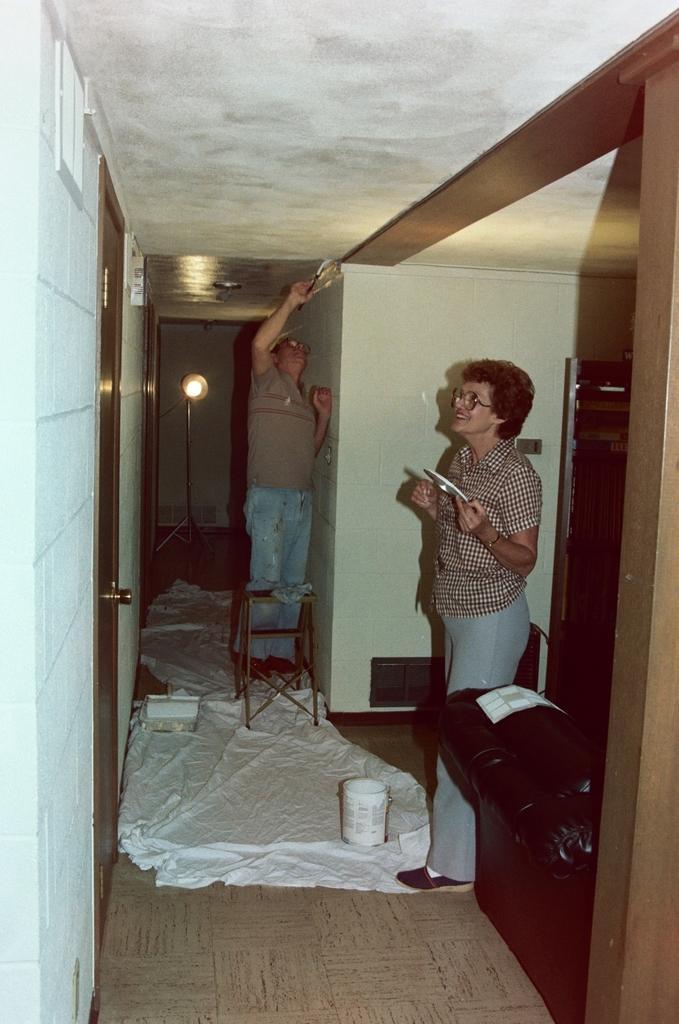How would you summarize this image in a sentence or two? In this image I can see two persons on the floor, cover and some objects. In the background I can see a wall, light, door and a chair. This image is taken may be in a hall. 